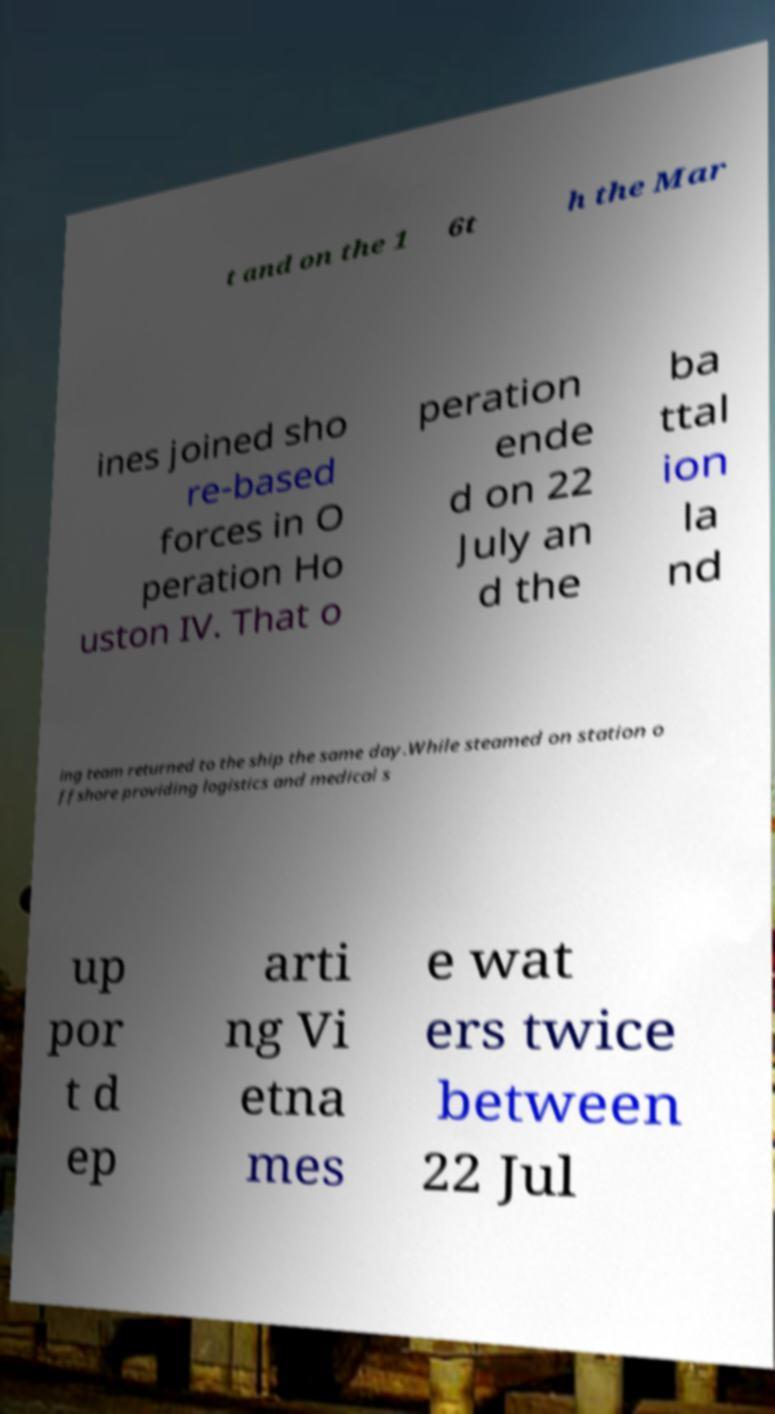For documentation purposes, I need the text within this image transcribed. Could you provide that? t and on the 1 6t h the Mar ines joined sho re-based forces in O peration Ho uston IV. That o peration ende d on 22 July an d the ba ttal ion la nd ing team returned to the ship the same day.While steamed on station o ffshore providing logistics and medical s up por t d ep arti ng Vi etna mes e wat ers twice between 22 Jul 